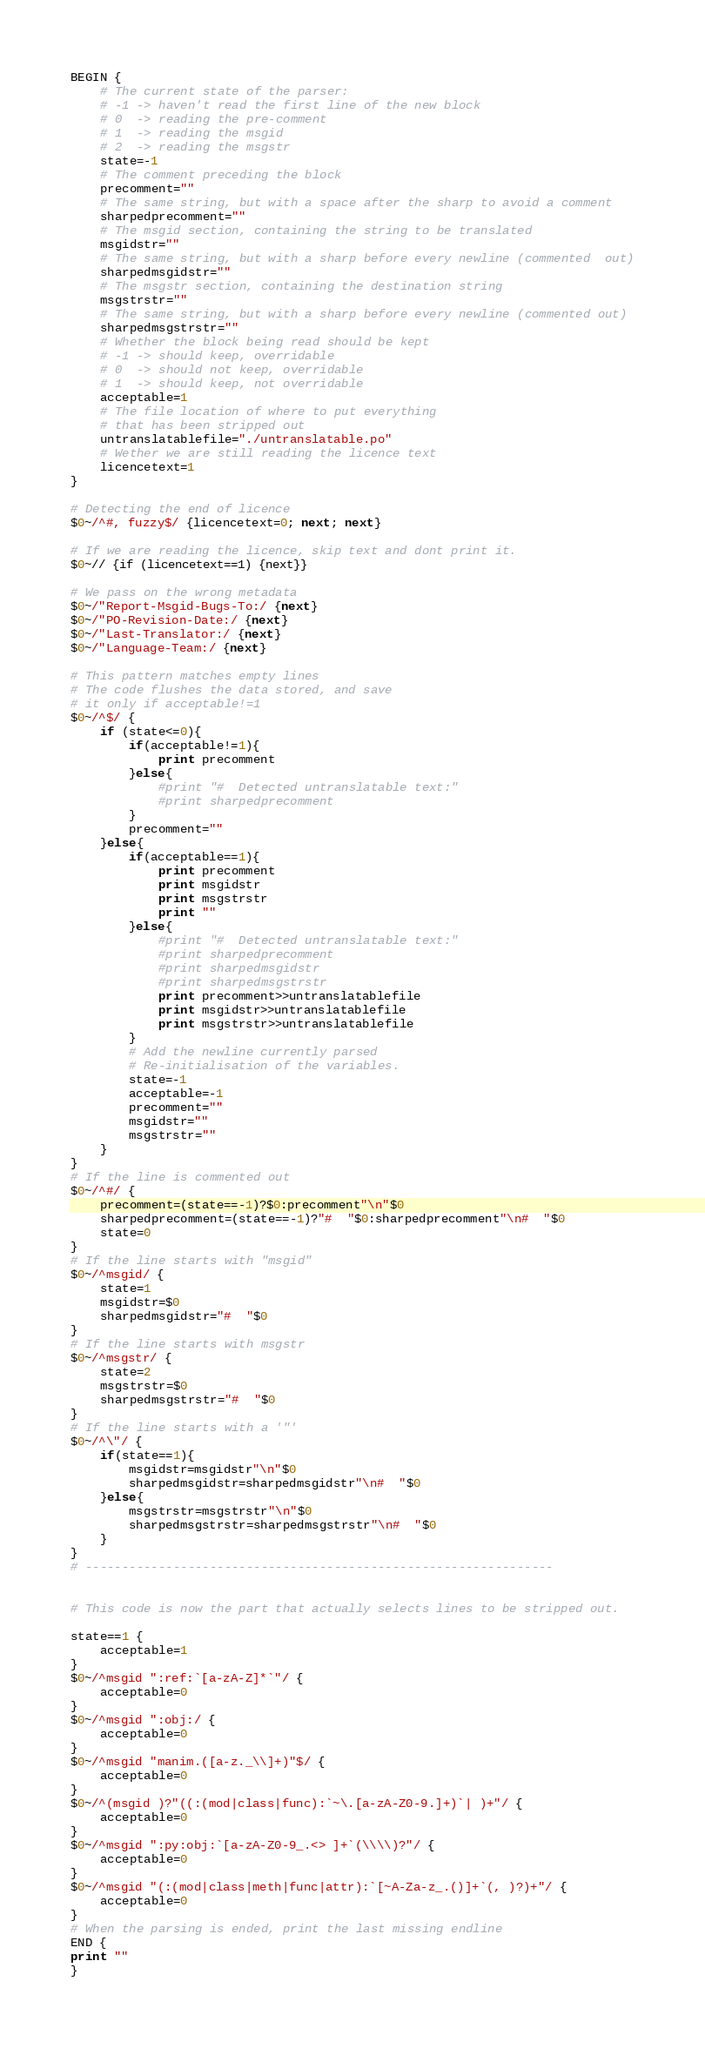<code> <loc_0><loc_0><loc_500><loc_500><_Awk_>BEGIN {
	# The current state of the parser:
	# -1 -> haven't read the first line of the new block
	# 0  -> reading the pre-comment
	# 1  -> reading the msgid
	# 2  -> reading the msgstr
	state=-1
	# The comment preceding the block
	precomment=""
	# The same string, but with a space after the sharp to avoid a comment
	sharpedprecomment=""
	# The msgid section, containing the string to be translated
	msgidstr=""
	# The same string, but with a sharp before every newline (commented  out)
	sharpedmsgidstr=""
	# The msgstr section, containing the destination string
	msgstrstr=""
	# The same string, but with a sharp before every newline (commented out)
	sharpedmsgstrstr=""
	# Whether the block being read should be kept
	# -1 -> should keep, overridable
	# 0  -> should not keep, overridable
	# 1  -> should keep, not overridable
	acceptable=1
	# The file location of where to put everything
	# that has been stripped out
	untranslatablefile="./untranslatable.po"
	# Wether we are still reading the licence text
	licencetext=1
}

# Detecting the end of licence
$0~/^#, fuzzy$/ {licencetext=0; next; next}

# If we are reading the licence, skip text and dont print it.
$0~// {if (licencetext==1) {next}}

# We pass on the wrong metadata
$0~/"Report-Msgid-Bugs-To:/ {next}
$0~/"PO-Revision-Date:/ {next}
$0~/"Last-Translator:/ {next}
$0~/"Language-Team:/ {next}

# This pattern matches empty lines
# The code flushes the data stored, and save
# it only if acceptable!=1
$0~/^$/ {
	if (state<=0){
		if(acceptable!=1){
			print precomment
		}else{
			#print "#  Detected untranslatable text:"
			#print sharpedprecomment
		}
		precomment=""
	}else{
		if(acceptable==1){
			print precomment
			print msgidstr
			print msgstrstr
			print ""
		}else{
			#print "#  Detected untranslatable text:"
			#print sharpedprecomment
			#print sharpedmsgidstr
			#print sharpedmsgstrstr
			print precomment>>untranslatablefile
			print msgidstr>>untranslatablefile
			print msgstrstr>>untranslatablefile
		}
		# Add the newline currently parsed
		# Re-initialisation of the variables.
		state=-1
		acceptable=-1
		precomment=""
		msgidstr=""
		msgstrstr=""
	}
}
# If the line is commented out
$0~/^#/ {
	precomment=(state==-1)?$0:precomment"\n"$0
	sharpedprecomment=(state==-1)?"#  "$0:sharpedprecomment"\n#  "$0
	state=0
}
# If the line starts with "msgid"
$0~/^msgid/ {
	state=1
	msgidstr=$0
	sharpedmsgidstr="#  "$0
}
# If the line starts with msgstr
$0~/^msgstr/ {
	state=2
	msgstrstr=$0
	sharpedmsgstrstr="#  "$0
}
# If the line starts with a '"'
$0~/^\"/ {
	if(state==1){
		msgidstr=msgidstr"\n"$0
		sharpedmsgidstr=sharpedmsgidstr"\n#  "$0
	}else{
		msgstrstr=msgstrstr"\n"$0
		sharpedmsgstrstr=sharpedmsgstrstr"\n#  "$0
	}
}
# ----------------------------------------------------------------


# This code is now the part that actually selects lines to be stripped out.

state==1 {
	acceptable=1
}
$0~/^msgid ":ref:`[a-zA-Z]*`"/ {
	acceptable=0
}
$0~/^msgid ":obj:/ {
	acceptable=0
}
$0~/^msgid "manim.([a-z._\\]+)"$/ {
	acceptable=0
}
$0~/^(msgid )?"((:(mod|class|func):`~\.[a-zA-Z0-9.]+)`| )+"/ {
	acceptable=0
}
$0~/^msgid ":py:obj:`[a-zA-Z0-9_.<> ]+`(\\\\)?"/ {
	acceptable=0
}
$0~/^msgid "(:(mod|class|meth|func|attr):`[~A-Za-z_.()]+`(, )?)+"/ {
	acceptable=0
}
# When the parsing is ended, print the last missing endline
END {
print ""
}
</code> 